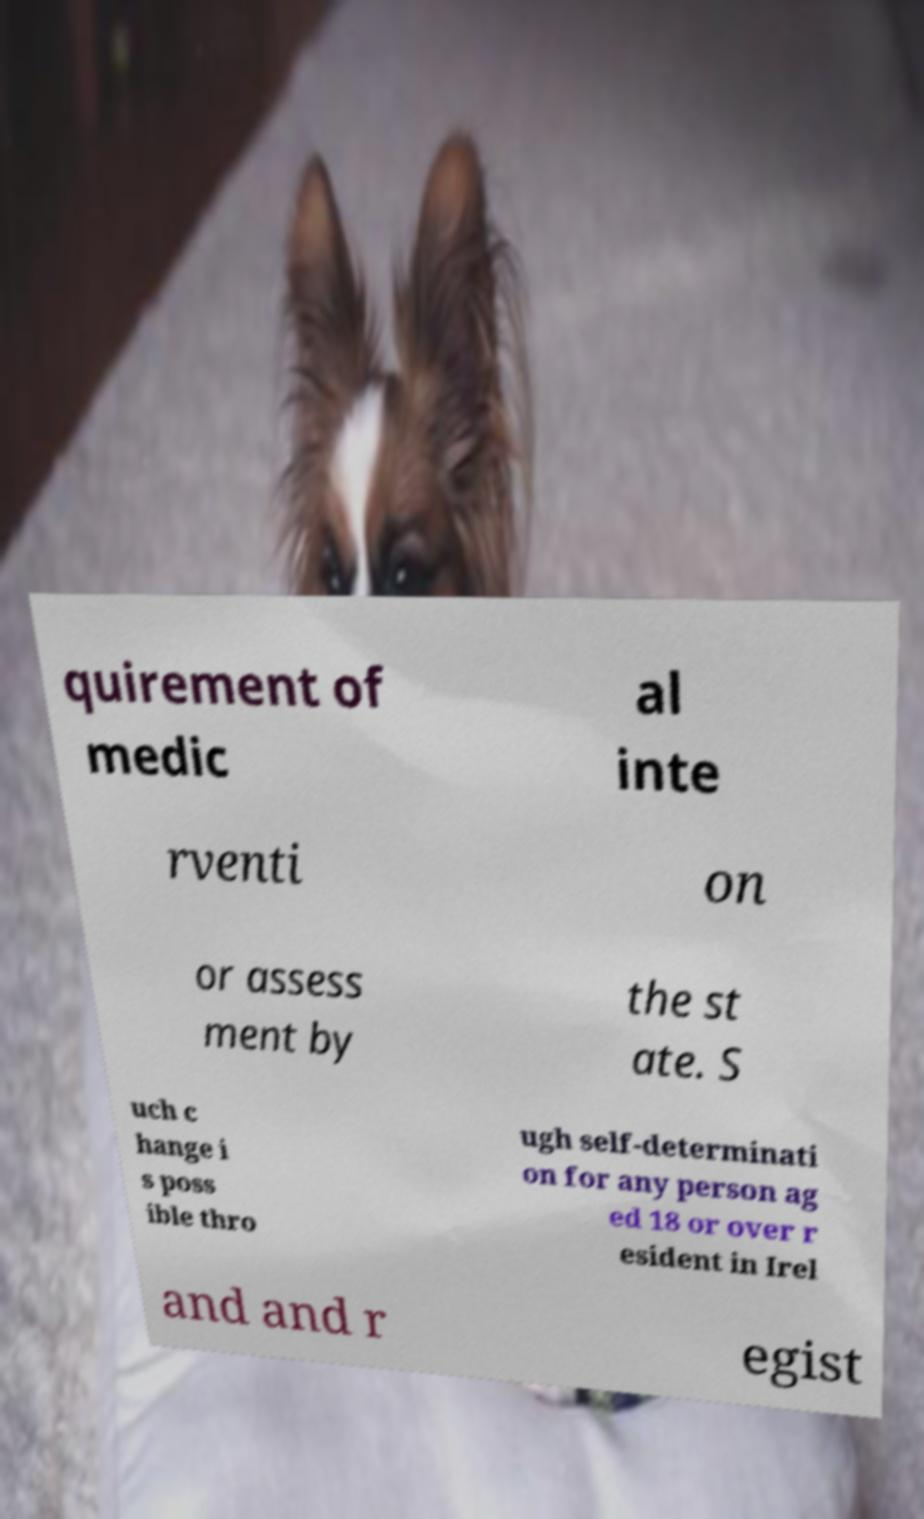Could you extract and type out the text from this image? quirement of medic al inte rventi on or assess ment by the st ate. S uch c hange i s poss ible thro ugh self-determinati on for any person ag ed 18 or over r esident in Irel and and r egist 